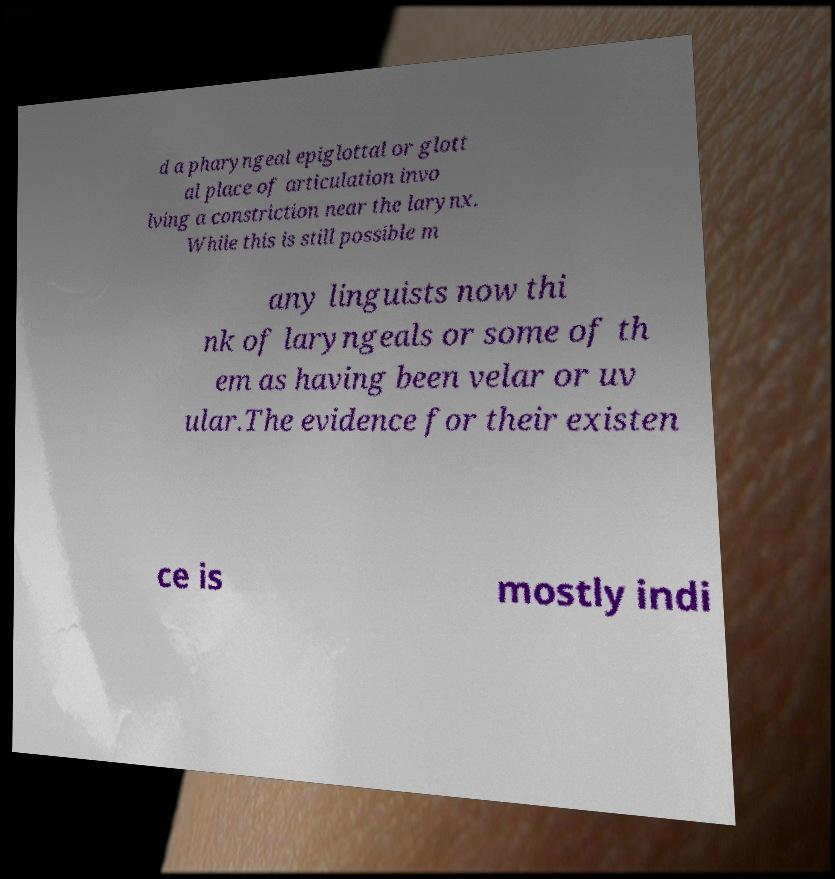Can you accurately transcribe the text from the provided image for me? d a pharyngeal epiglottal or glott al place of articulation invo lving a constriction near the larynx. While this is still possible m any linguists now thi nk of laryngeals or some of th em as having been velar or uv ular.The evidence for their existen ce is mostly indi 